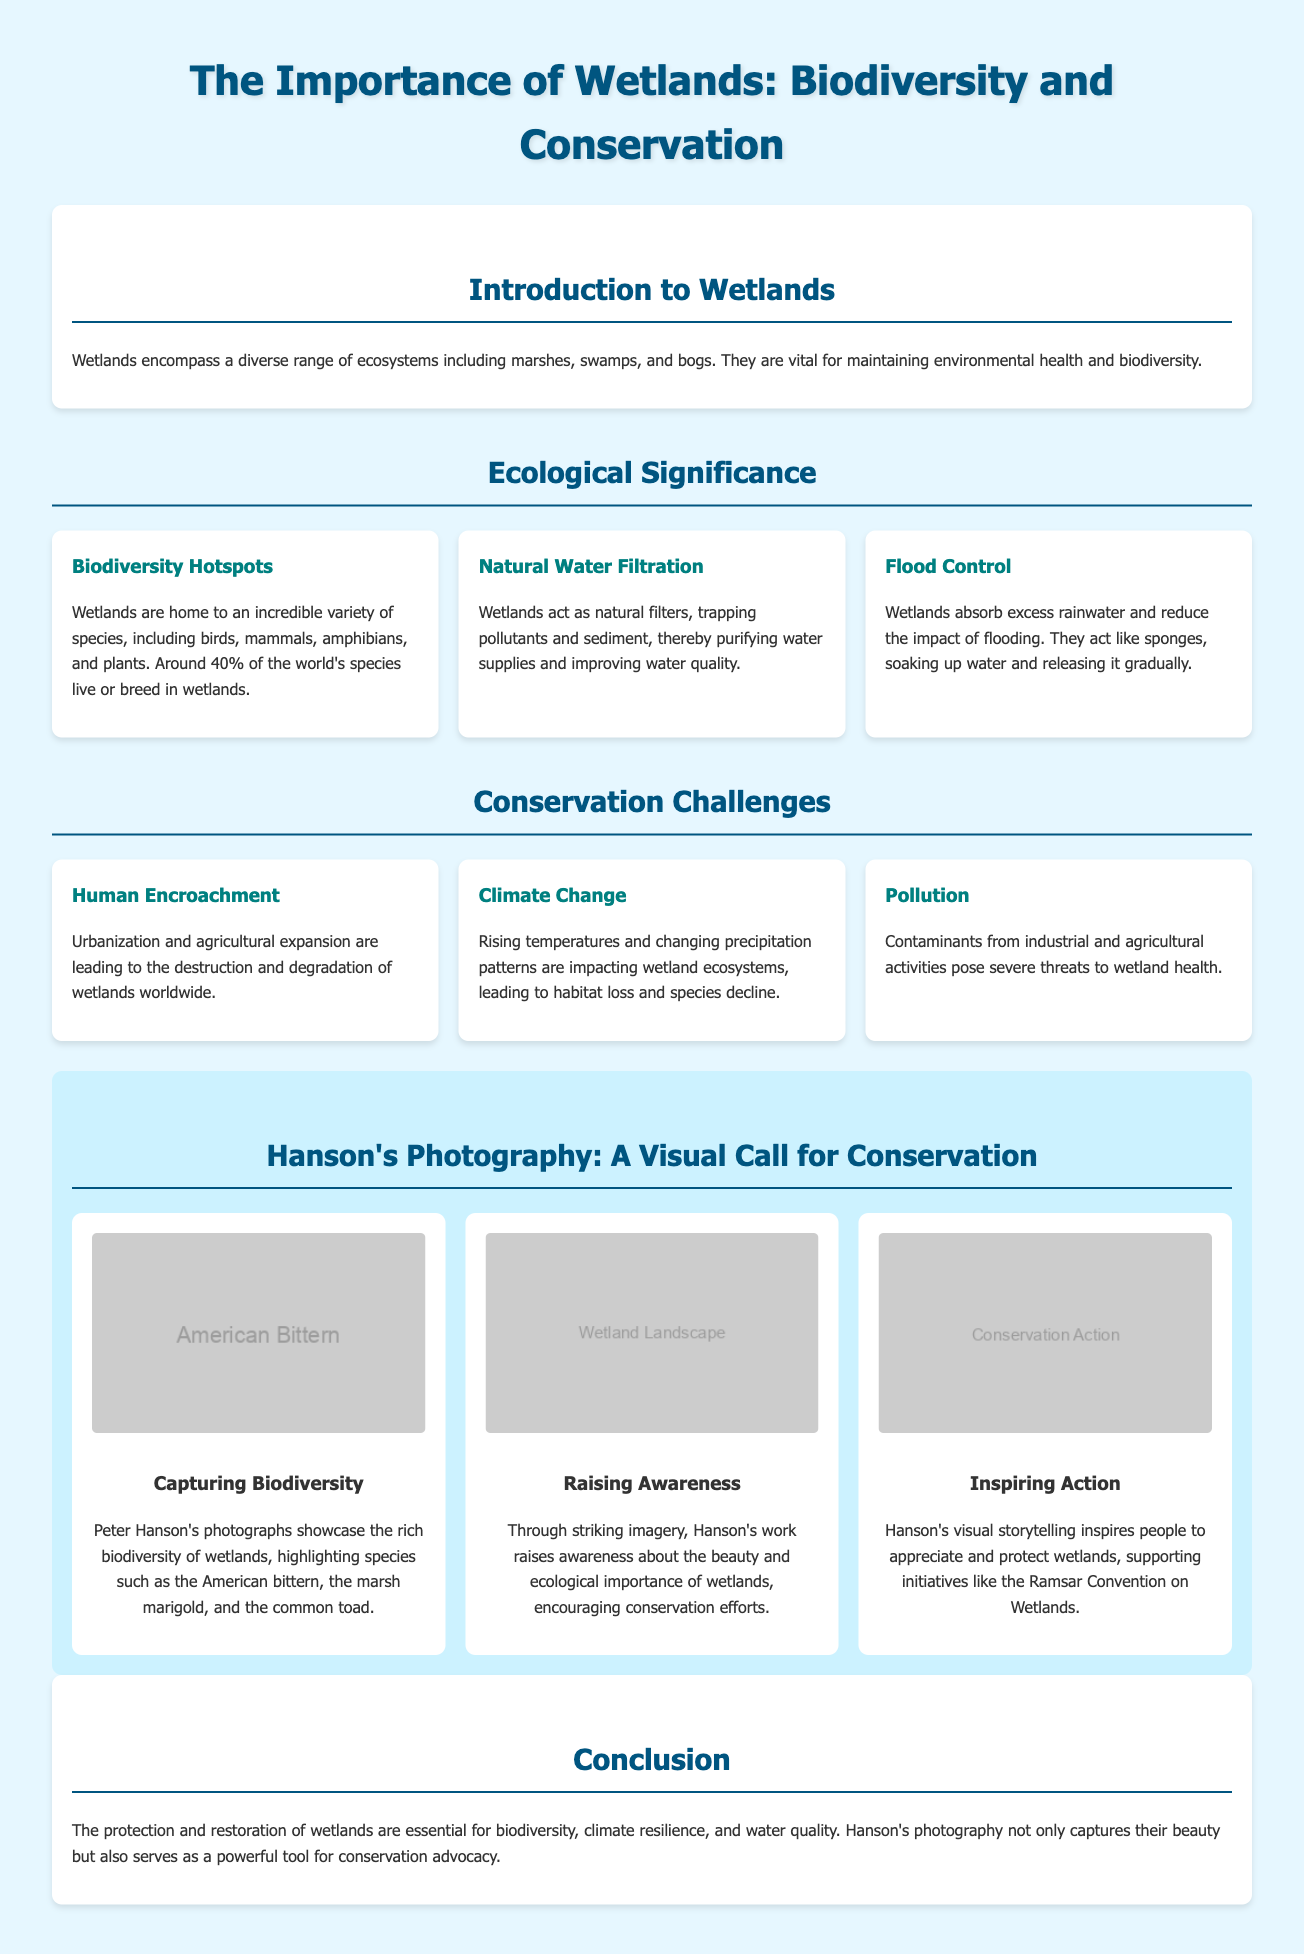what percentage of the world's species live or breed in wetlands? The document states that around 40% of the world's species live or breed in wetlands.
Answer: 40% what role do wetlands play in flood control? Wetlands absorb excess rainwater and reduce the impact of flooding.
Answer: Absorb excess rainwater who is the photographer highlighted in the document? The document discusses the photography of Peter Hanson.
Answer: Peter Hanson what is a primary threat to wetlands mentioned in the document? The document identifies human encroachment as a primary threat to wetlands.
Answer: Human encroachment what is one of the species showcased in Hanson's photographs? One of the species highlighted in the photographs is the American bittern.
Answer: American bittern how does Hanson’s photography contribute to conservation? Hanson's photography raises awareness about the beauty and ecological importance of wetlands.
Answer: Raises awareness what does the Ramsar Convention pertain to? The Ramsar Convention is focused on wetland conservation initiatives.
Answer: Wetland conservation what type of ecosystems do wetlands include? The document mentions marshes, swamps, and bogs as examples of wetlands.
Answer: Marshes, swamps, bogs how does pollution affect wetlands according to the document? Pollutants from industrial and agricultural activities pose severe threats to wetland health.
Answer: Severe threats to health 